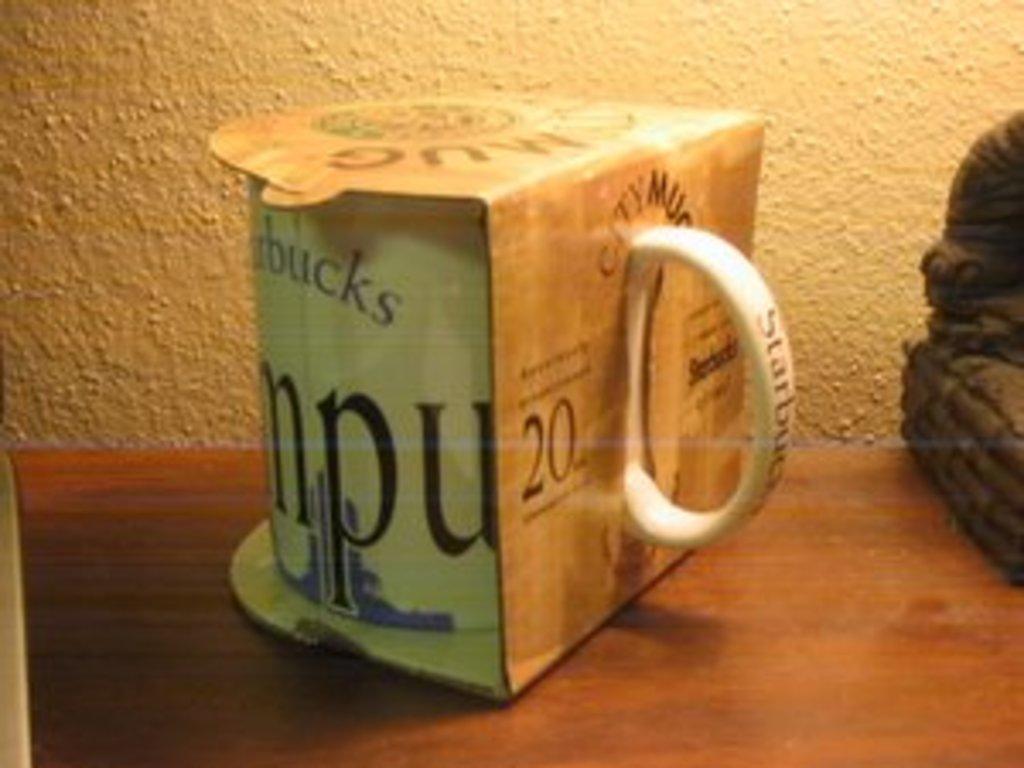Describe this image in one or two sentences. It is a cup which is in the box made up of paper and this is the wall. 